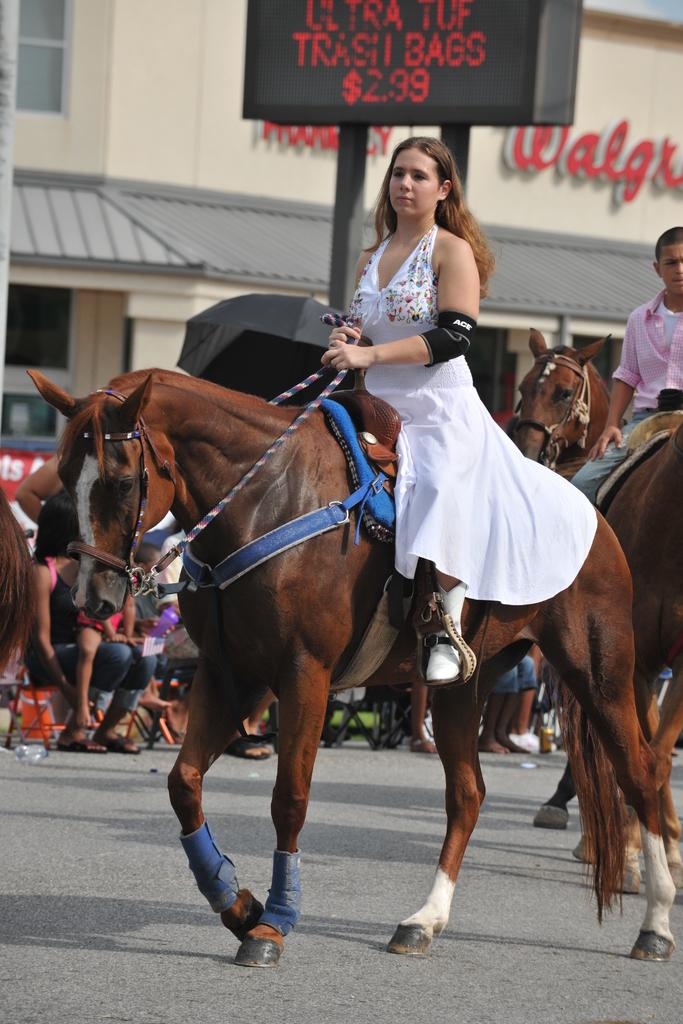What type of structure is visible in the image? There is a building in the image. What are the people in the image doing? There are people sitting on chairs in the image. Can you describe the people in the front of the image? There are two people sitting on horses in the front of the image. What time of day is the person offering a drink in the image? There is no person offering a drink in the image. What type of person is sitting on the horse in the afternoon? There is no person sitting on a horse in the afternoon, as the image does not specify a time of day. 